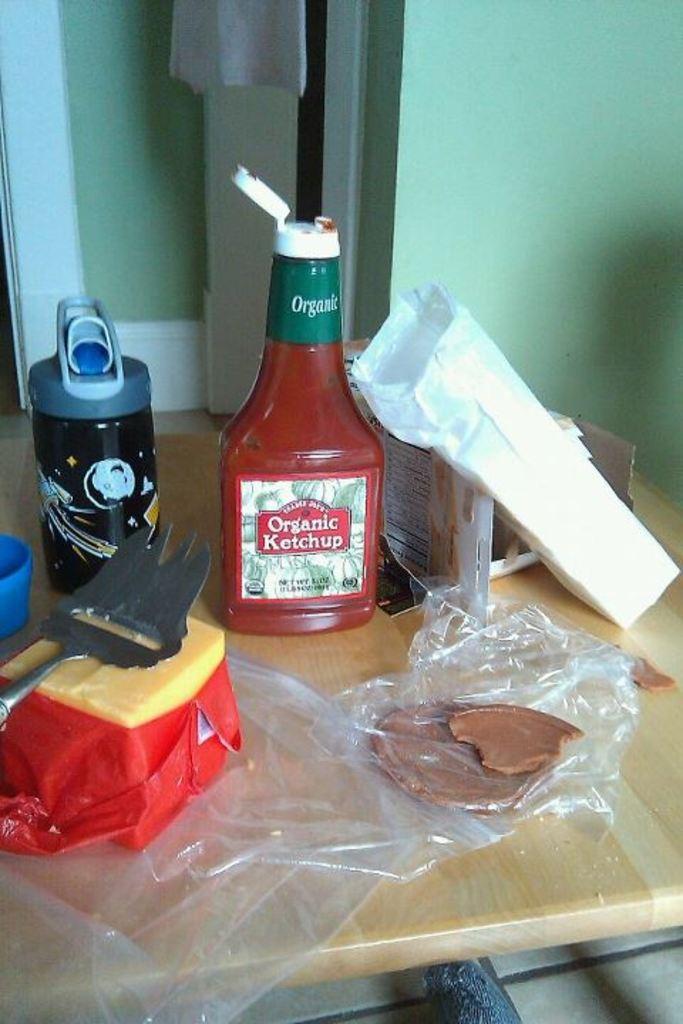Is this ketchup organic?
Provide a succinct answer. Yes. 